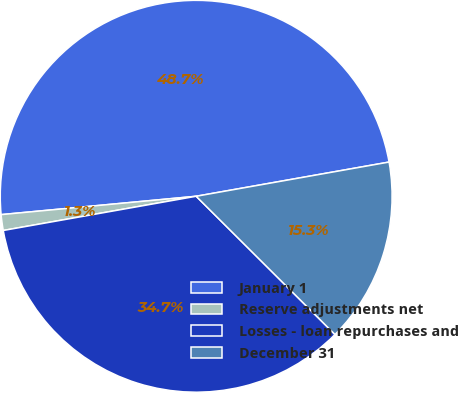Convert chart to OTSL. <chart><loc_0><loc_0><loc_500><loc_500><pie_chart><fcel>January 1<fcel>Reserve adjustments net<fcel>Losses - loan repurchases and<fcel>December 31<nl><fcel>48.7%<fcel>1.3%<fcel>34.74%<fcel>15.26%<nl></chart> 